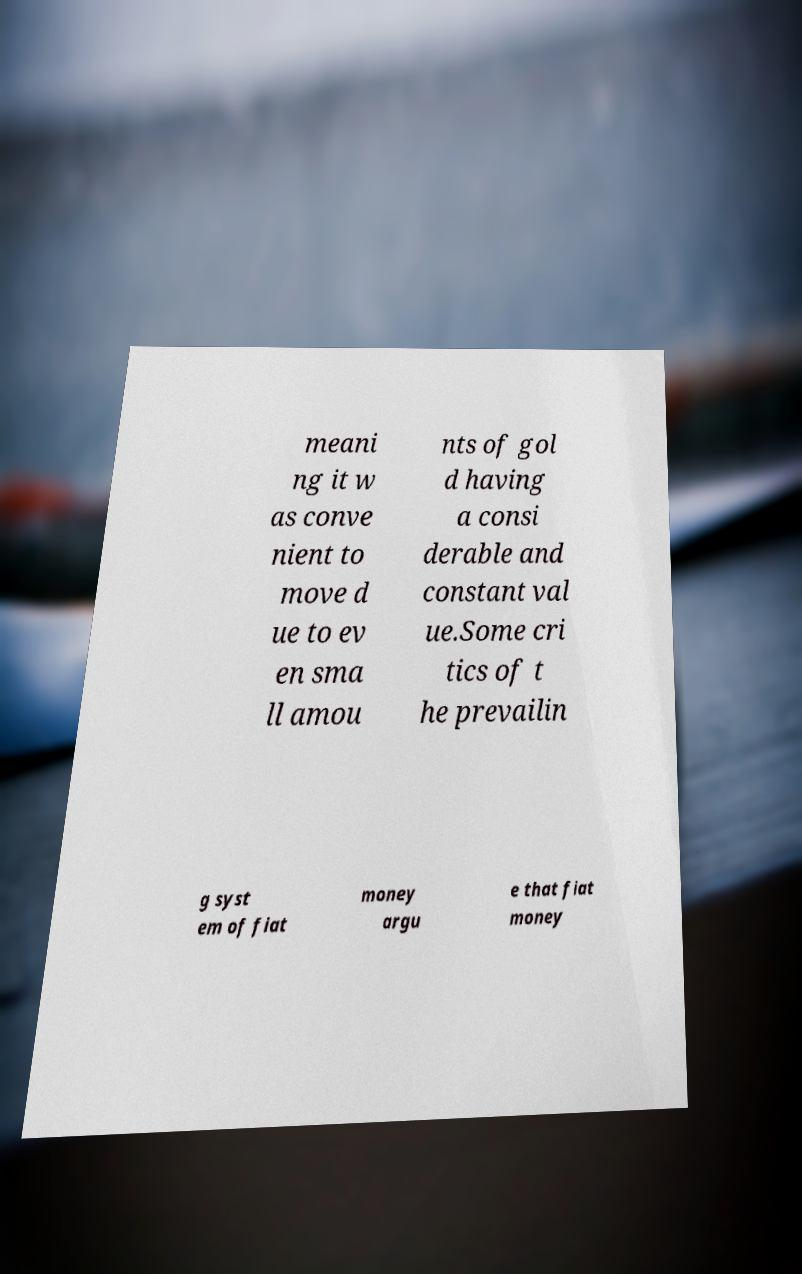I need the written content from this picture converted into text. Can you do that? meani ng it w as conve nient to move d ue to ev en sma ll amou nts of gol d having a consi derable and constant val ue.Some cri tics of t he prevailin g syst em of fiat money argu e that fiat money 